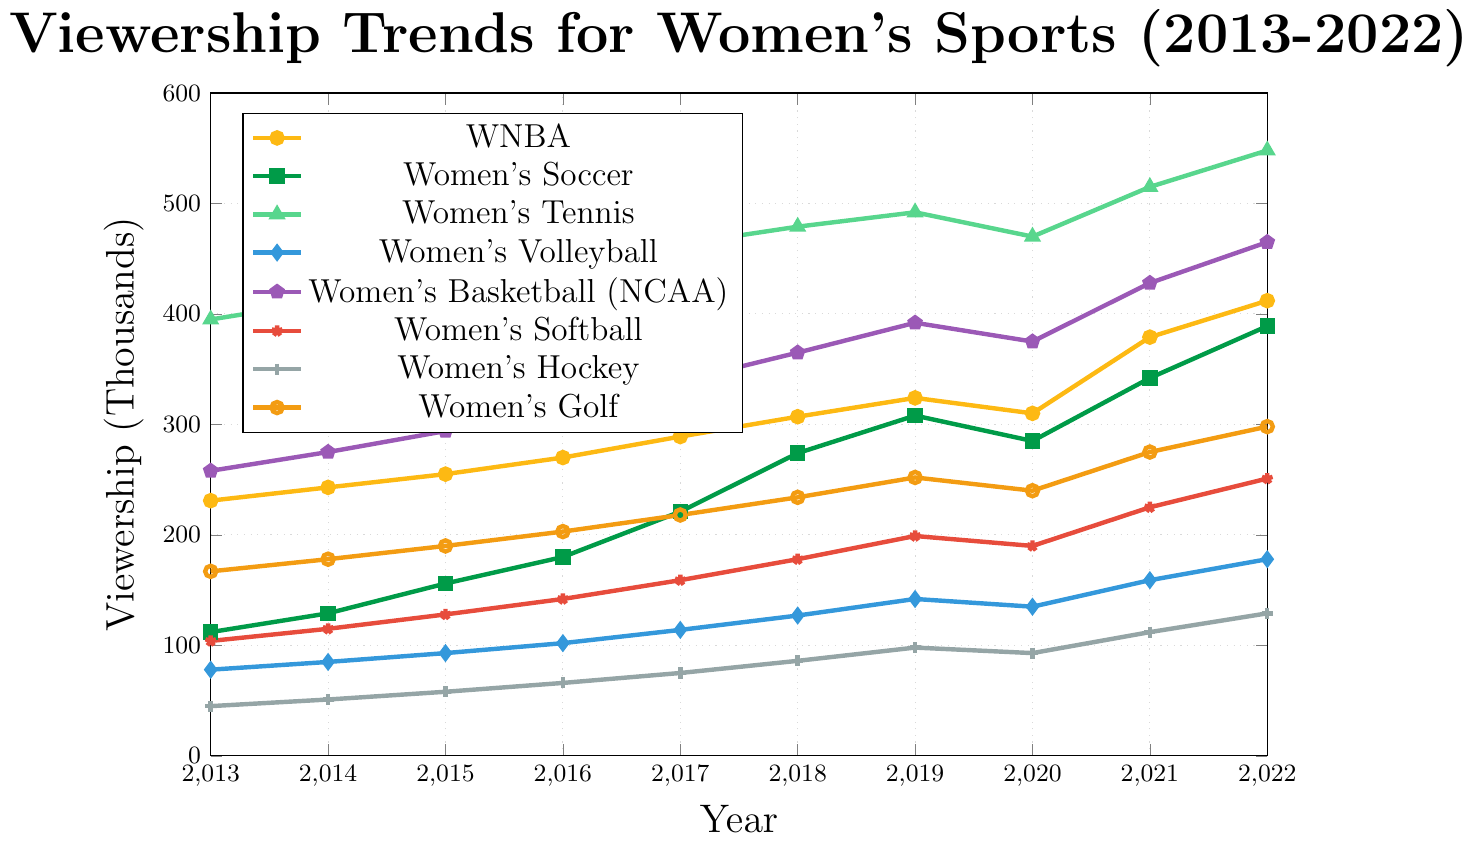What is the trend in viewership for the WNBA from 2013 to 2022? Look at the line corresponding to the WNBA, it shows an upward trajectory from 2013 to 2022 with a slight dip in 2020.
Answer: Increasing, with a dip in 2020 Which sport had the highest viewership in 2022? Identify the highest point on the y-axis for the year 2022 and check the legend for the corresponding sport. Women's Tennis shows the highest value.
Answer: Women's Tennis By how much did viewership for Women's Soccer increase from 2013 to 2022? Subtract the viewership number for Women's Soccer in 2013 from the viewership number in 2022 (389,000 - 112,000).
Answer: 277,000 Which two sports had nearly equal viewership trends in 2020? Compare the viewership numbers for all sports in the year 2020, identify close values. Both WNBA and Women's Basketball (NCAA) had close viewership numbers around 310,000 and 375,000, respectively.
Answer: WNBA and Women’s Basketball (NCAA) What is the average viewership for Women's Golf across the decade? Sum the viewership figures for Women's Golf from 2013 to 2022 and divide by the number of years (10). (167 + 178 + 190 + 203 + 218 + 234 + 252 + 240 + 275 + 298) = 2255; 2255 / 10 = 225.5
Answer: 225.5 Which sport saw the most significant gain in viewership from 2013 to 2022? Calculate the absolute increase for each sport by subtracting the viewership number in 2013 from that in 2022 and compare the results. Women’s Tennis had the largest increase: 548,000 - 395,000 = 153,000.
Answer: Women’s Tennis Compare the viewership trends for Women's Hockey and Women's Softball. Which sport had a higher viewership in the final year? Look at the values for Women's Hockey and Women's Softball in 2022, 129,000 for Hockey and 251,000 for Softball.
Answer: Women's Softball What is the overall trend for Women's Volleyball from 2013 to 2022? Observe the line for Women's Volleyball; it shows consistent growth from 2013 to 2022.
Answer: Increasing Describe the shape of the viewership trend for Women's Soccer. The line for Women's Soccer generally trends up, with some fluctuations, showing a significant rise around 2018 and a brief decrease in 2020.
Answer: Increasing with fluctuations 